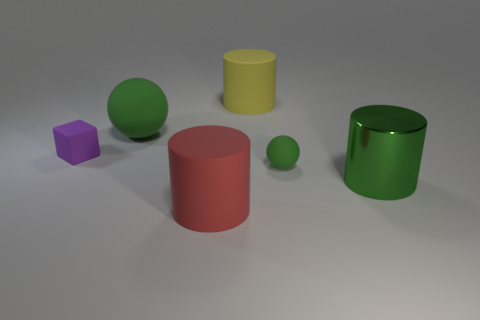How many green spheres must be subtracted to get 1 green spheres? 1 Add 1 red blocks. How many objects exist? 7 Subtract all blocks. How many objects are left? 5 Subtract 1 yellow cylinders. How many objects are left? 5 Subtract all big green metal things. Subtract all red things. How many objects are left? 4 Add 1 purple objects. How many purple objects are left? 2 Add 5 yellow things. How many yellow things exist? 6 